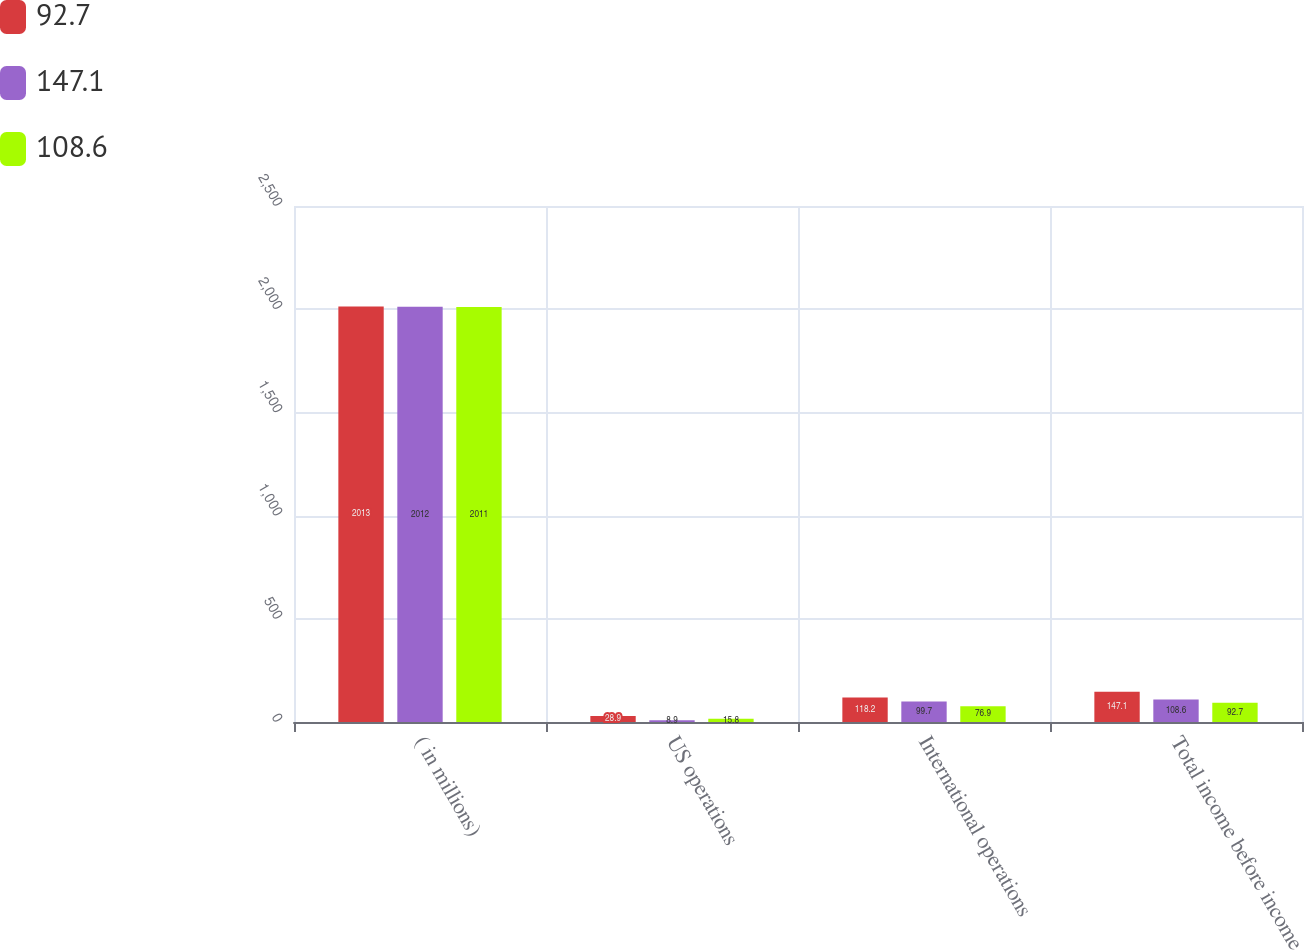<chart> <loc_0><loc_0><loc_500><loc_500><stacked_bar_chart><ecel><fcel>( in millions)<fcel>US operations<fcel>International operations<fcel>Total income before income<nl><fcel>92.7<fcel>2013<fcel>28.9<fcel>118.2<fcel>147.1<nl><fcel>147.1<fcel>2012<fcel>8.9<fcel>99.7<fcel>108.6<nl><fcel>108.6<fcel>2011<fcel>15.8<fcel>76.9<fcel>92.7<nl></chart> 